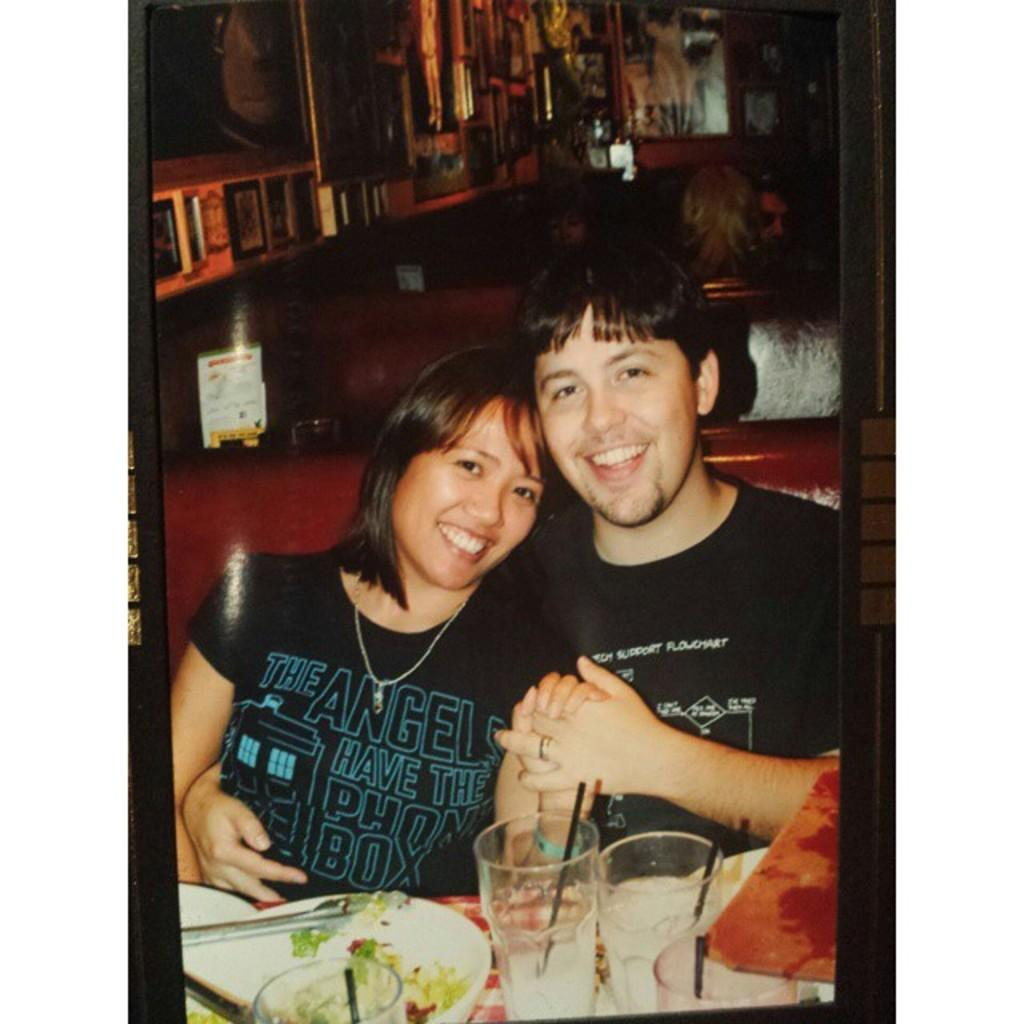What are the people in the image doing? The people in the image are sitting. What objects can be seen on the table in the image? There are glasses and plates visible in the image. What is on the wall in the image? There is a wall with frames in the image. What type of objects have text written on them in the image? There are boards with text in the image. What type of instrument is being played by the people in the image? There is no instrument being played by the people in the image. What type of soap is visible in the image? There is no soap present in the image. 